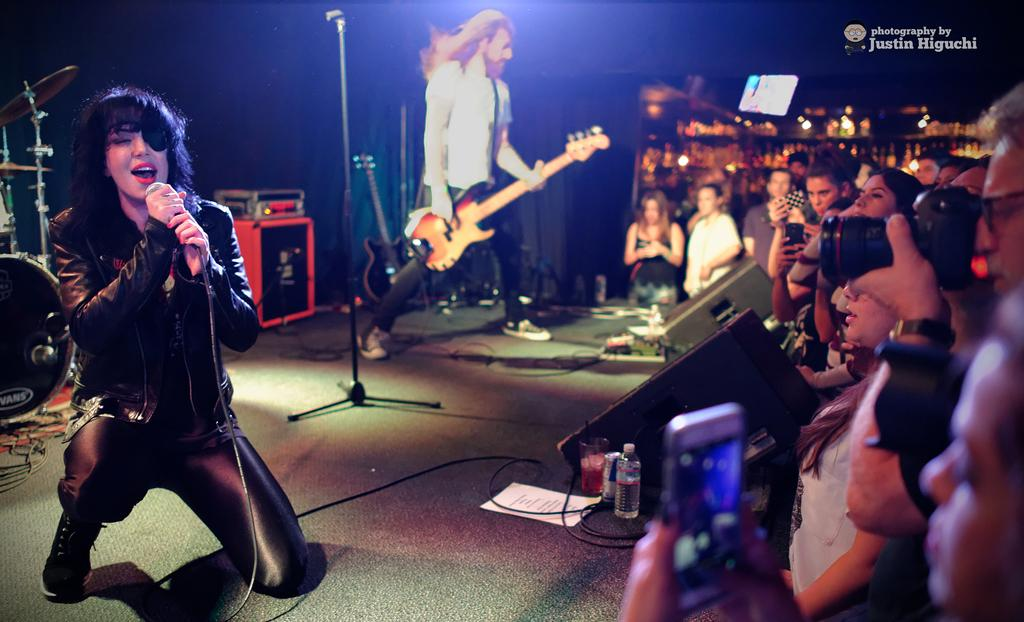What is happening in the image? There is a group of people in the image, and a woman is singing on stage. Are there any musicians present in the image? Yes, there is a person playing a guitar on stage. What type of shade is being provided for the baby in the image? There is no baby present in the image, so there is no shade being provided for a baby. 